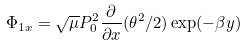Convert formula to latex. <formula><loc_0><loc_0><loc_500><loc_500>\Phi _ { 1 x } = \sqrt { \mu } P _ { 0 } ^ { 2 } \frac { \partial } { \partial x } ( \theta ^ { 2 } / 2 ) \exp ( - \beta y )</formula> 